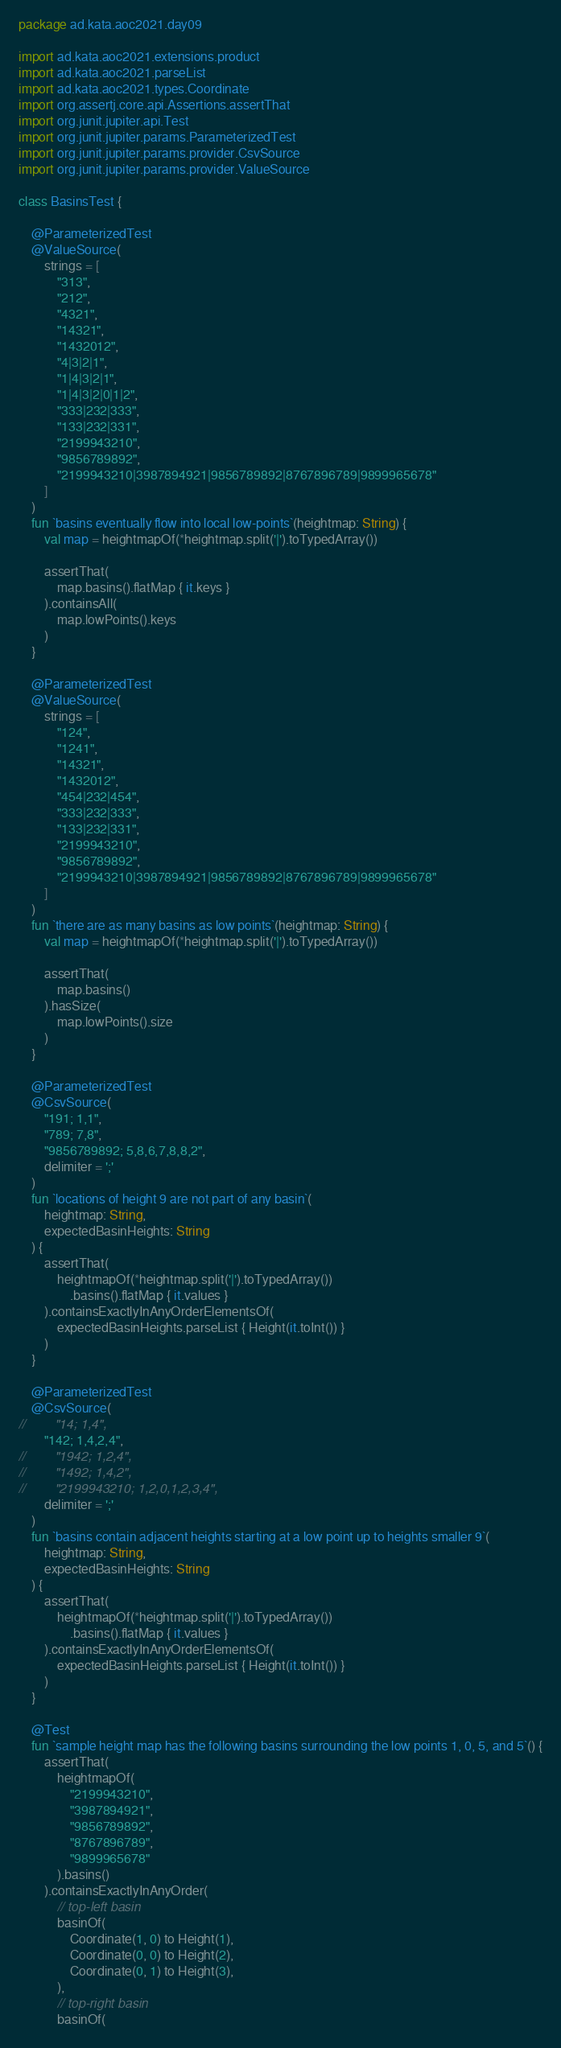Convert code to text. <code><loc_0><loc_0><loc_500><loc_500><_Kotlin_>package ad.kata.aoc2021.day09

import ad.kata.aoc2021.extensions.product
import ad.kata.aoc2021.parseList
import ad.kata.aoc2021.types.Coordinate
import org.assertj.core.api.Assertions.assertThat
import org.junit.jupiter.api.Test
import org.junit.jupiter.params.ParameterizedTest
import org.junit.jupiter.params.provider.CsvSource
import org.junit.jupiter.params.provider.ValueSource

class BasinsTest {

    @ParameterizedTest
    @ValueSource(
        strings = [
            "313",
            "212",
            "4321",
            "14321",
            "1432012",
            "4|3|2|1",
            "1|4|3|2|1",
            "1|4|3|2|0|1|2",
            "333|232|333",
            "133|232|331",
            "2199943210",
            "9856789892",
            "2199943210|3987894921|9856789892|8767896789|9899965678"
        ]
    )
    fun `basins eventually flow into local low-points`(heightmap: String) {
        val map = heightmapOf(*heightmap.split('|').toTypedArray())

        assertThat(
            map.basins().flatMap { it.keys }
        ).containsAll(
            map.lowPoints().keys
        )
    }

    @ParameterizedTest
    @ValueSource(
        strings = [
            "124",
            "1241",
            "14321",
            "1432012",
            "454|232|454",
            "333|232|333",
            "133|232|331",
            "2199943210",
            "9856789892",
            "2199943210|3987894921|9856789892|8767896789|9899965678"
        ]
    )
    fun `there are as many basins as low points`(heightmap: String) {
        val map = heightmapOf(*heightmap.split('|').toTypedArray())

        assertThat(
            map.basins()
        ).hasSize(
            map.lowPoints().size
        )
    }

    @ParameterizedTest
    @CsvSource(
        "191; 1,1",
        "789; 7,8",
        "9856789892; 5,8,6,7,8,8,2",
        delimiter = ';'
    )
    fun `locations of height 9 are not part of any basin`(
        heightmap: String,
        expectedBasinHeights: String
    ) {
        assertThat(
            heightmapOf(*heightmap.split('|').toTypedArray())
                .basins().flatMap { it.values }
        ).containsExactlyInAnyOrderElementsOf(
            expectedBasinHeights.parseList { Height(it.toInt()) }
        )
    }

    @ParameterizedTest
    @CsvSource(
//        "14; 1,4",
        "142; 1,4,2,4",
//        "1942; 1,2,4",
//        "1492; 1,4,2",
//        "2199943210; 1,2,0,1,2,3,4",
        delimiter = ';'
    )
    fun `basins contain adjacent heights starting at a low point up to heights smaller 9`(
        heightmap: String,
        expectedBasinHeights: String
    ) {
        assertThat(
            heightmapOf(*heightmap.split('|').toTypedArray())
                .basins().flatMap { it.values }
        ).containsExactlyInAnyOrderElementsOf(
            expectedBasinHeights.parseList { Height(it.toInt()) }
        )
    }

    @Test
    fun `sample height map has the following basins surrounding the low points 1, 0, 5, and 5`() {
        assertThat(
            heightmapOf(
                "2199943210",
                "3987894921",
                "9856789892",
                "8767896789",
                "9899965678"
            ).basins()
        ).containsExactlyInAnyOrder(
            // top-left basin
            basinOf(
                Coordinate(1, 0) to Height(1),
                Coordinate(0, 0) to Height(2),
                Coordinate(0, 1) to Height(3),
            ),
            // top-right basin
            basinOf(</code> 